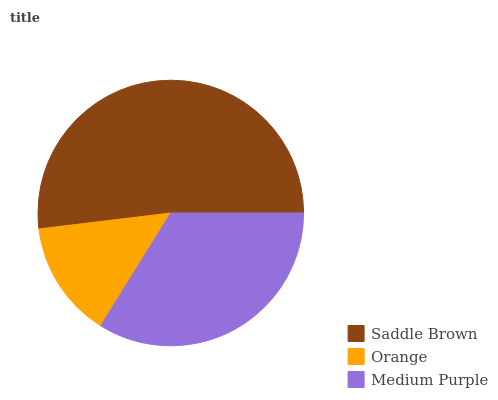Is Orange the minimum?
Answer yes or no. Yes. Is Saddle Brown the maximum?
Answer yes or no. Yes. Is Medium Purple the minimum?
Answer yes or no. No. Is Medium Purple the maximum?
Answer yes or no. No. Is Medium Purple greater than Orange?
Answer yes or no. Yes. Is Orange less than Medium Purple?
Answer yes or no. Yes. Is Orange greater than Medium Purple?
Answer yes or no. No. Is Medium Purple less than Orange?
Answer yes or no. No. Is Medium Purple the high median?
Answer yes or no. Yes. Is Medium Purple the low median?
Answer yes or no. Yes. Is Orange the high median?
Answer yes or no. No. Is Saddle Brown the low median?
Answer yes or no. No. 